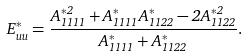<formula> <loc_0><loc_0><loc_500><loc_500>E ^ { * } _ { u u } = \frac { A _ { 1 1 1 1 } ^ { * 2 } + A _ { 1 1 1 1 } ^ { * } A _ { 1 1 2 2 } ^ { * } - 2 A _ { 1 1 2 2 } ^ { * 2 } } { A _ { 1 1 1 1 } ^ { * } + A _ { 1 1 2 2 } ^ { * } } .</formula> 